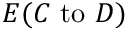Convert formula to latex. <formula><loc_0><loc_0><loc_500><loc_500>E ( C { t o } D )</formula> 